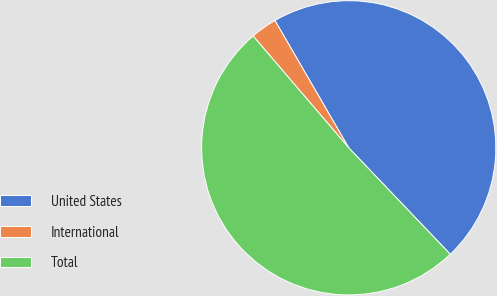Convert chart to OTSL. <chart><loc_0><loc_0><loc_500><loc_500><pie_chart><fcel>United States<fcel>International<fcel>Total<nl><fcel>46.24%<fcel>2.9%<fcel>50.86%<nl></chart> 